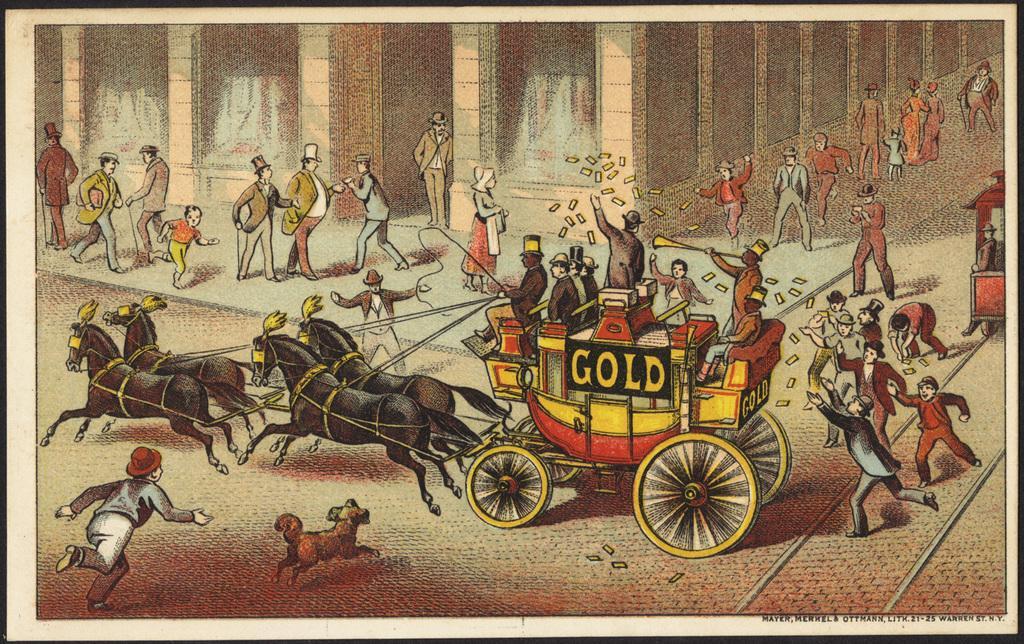Can you describe this image briefly? In this image there is a cartoon, in that there is a horse cart in that people are sitting in the background people are running, beside the car there is a footpath, on that footpath people are walking and there is a building, near the cart there is dog and man running. 